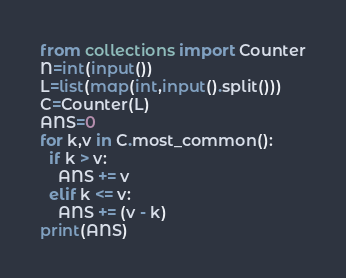Convert code to text. <code><loc_0><loc_0><loc_500><loc_500><_Python_>from collections import Counter
N=int(input())
L=list(map(int,input().split()))
C=Counter(L)
ANS=0
for k,v in C.most_common():
  if k > v:
    ANS += v
  elif k <= v:
    ANS += (v - k)
print(ANS)</code> 